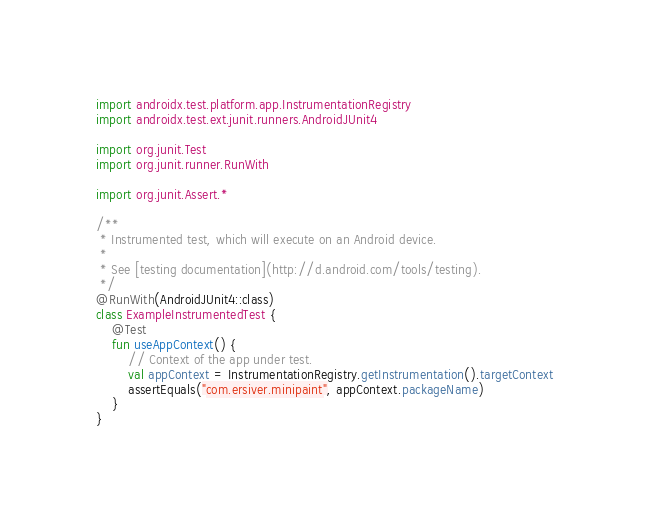<code> <loc_0><loc_0><loc_500><loc_500><_Kotlin_>
import androidx.test.platform.app.InstrumentationRegistry
import androidx.test.ext.junit.runners.AndroidJUnit4

import org.junit.Test
import org.junit.runner.RunWith

import org.junit.Assert.*

/**
 * Instrumented test, which will execute on an Android device.
 *
 * See [testing documentation](http://d.android.com/tools/testing).
 */
@RunWith(AndroidJUnit4::class)
class ExampleInstrumentedTest {
    @Test
    fun useAppContext() {
        // Context of the app under test.
        val appContext = InstrumentationRegistry.getInstrumentation().targetContext
        assertEquals("com.ersiver.minipaint", appContext.packageName)
    }
}
</code> 